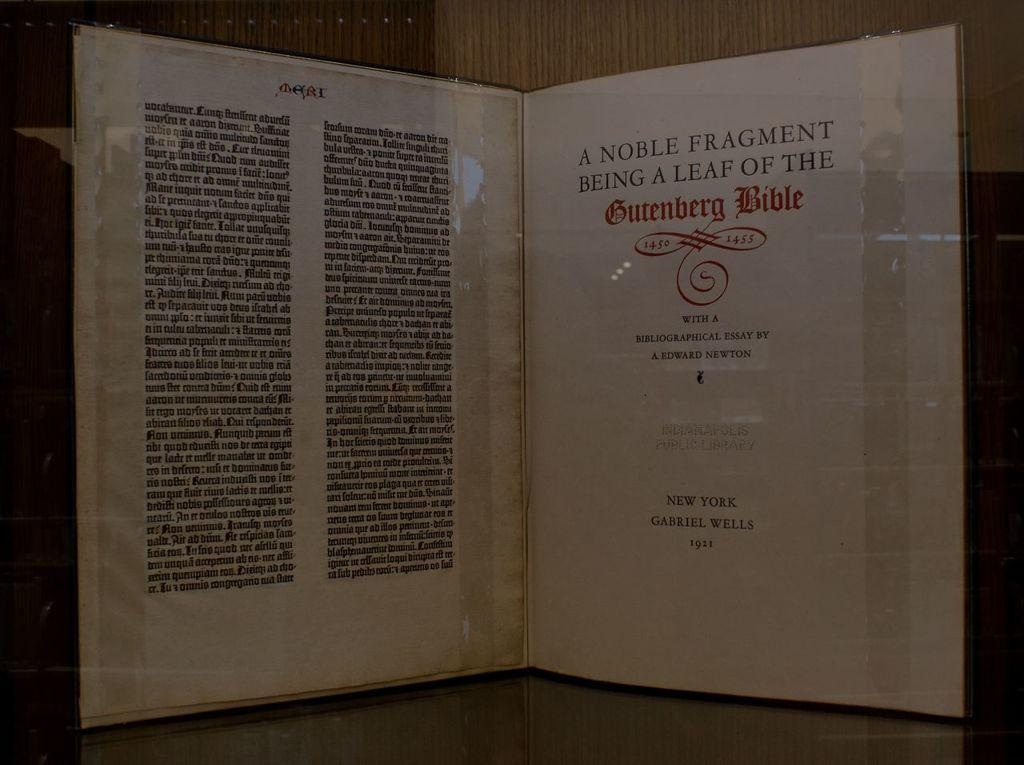<image>
Present a compact description of the photo's key features. Pages from A Noble Fragment Being a Leaf of the Gutenberg Bible 